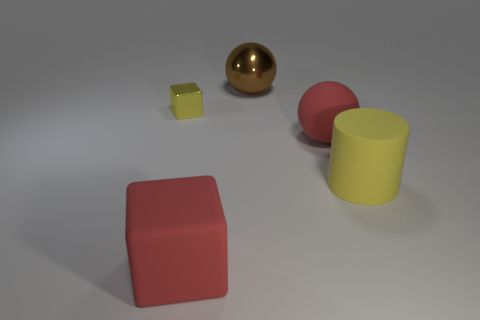Add 3 tiny blue metal cylinders. How many objects exist? 8 Subtract all blocks. How many objects are left? 3 Add 1 large green shiny cylinders. How many large green shiny cylinders exist? 1 Subtract 0 gray balls. How many objects are left? 5 Subtract all small blocks. Subtract all large red rubber spheres. How many objects are left? 3 Add 3 brown metallic objects. How many brown metallic objects are left? 4 